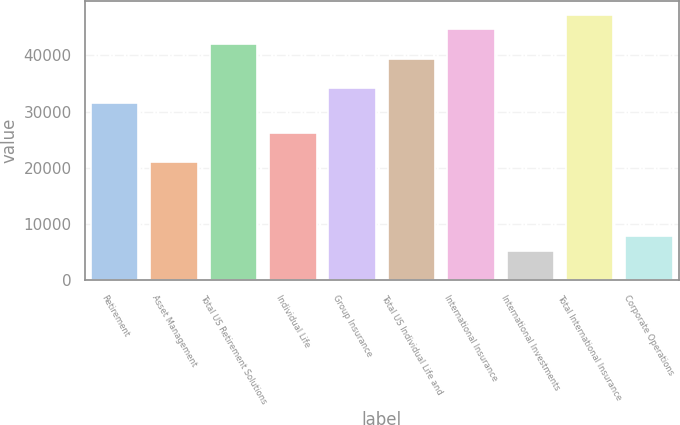Convert chart. <chart><loc_0><loc_0><loc_500><loc_500><bar_chart><fcel>Retirement<fcel>Asset Management<fcel>Total US Retirement Solutions<fcel>Individual Life<fcel>Group Insurance<fcel>Total US Individual Life and<fcel>International Insurance<fcel>International Investments<fcel>Total International Insurance<fcel>Corporate Operations<nl><fcel>31522<fcel>21016<fcel>42028<fcel>26269<fcel>34148.5<fcel>39401.5<fcel>44654.5<fcel>5257.02<fcel>47281<fcel>7883.52<nl></chart> 